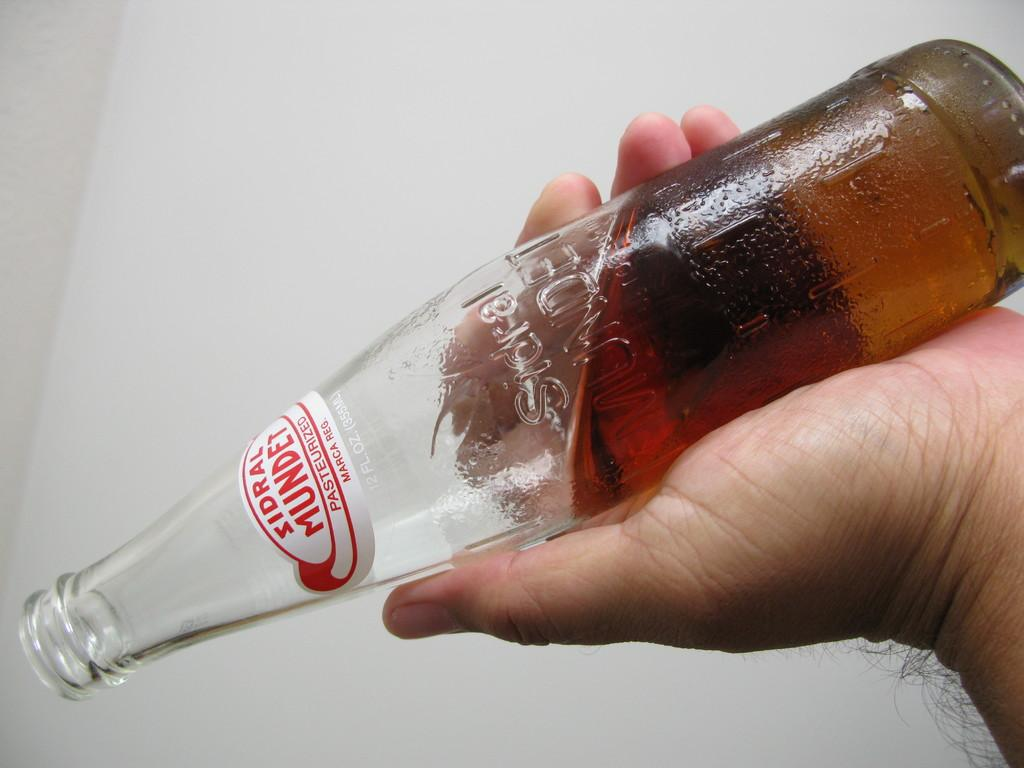<image>
Provide a brief description of the given image. A bottle is turned upside down and is the brand Sindral Mundet. 